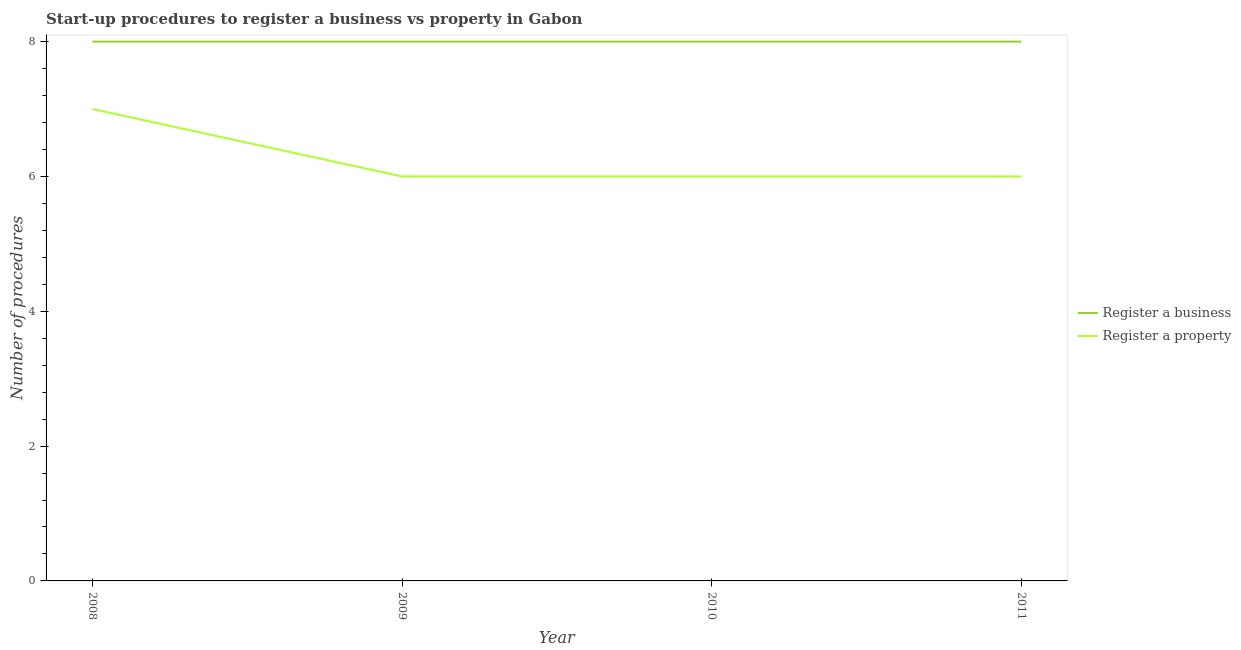Is the number of lines equal to the number of legend labels?
Provide a succinct answer. Yes. What is the number of procedures to register a business in 2009?
Provide a succinct answer. 8. Across all years, what is the maximum number of procedures to register a business?
Provide a succinct answer. 8. Across all years, what is the minimum number of procedures to register a property?
Your response must be concise. 6. In which year was the number of procedures to register a business maximum?
Provide a short and direct response. 2008. What is the total number of procedures to register a business in the graph?
Your answer should be very brief. 32. What is the difference between the number of procedures to register a property in 2009 and the number of procedures to register a business in 2008?
Offer a very short reply. -2. What is the average number of procedures to register a business per year?
Make the answer very short. 8. In the year 2009, what is the difference between the number of procedures to register a business and number of procedures to register a property?
Your answer should be compact. 2. In how many years, is the number of procedures to register a business greater than 7.2?
Your answer should be very brief. 4. Is the number of procedures to register a property in 2009 less than that in 2011?
Provide a short and direct response. No. Is the difference between the number of procedures to register a business in 2008 and 2011 greater than the difference between the number of procedures to register a property in 2008 and 2011?
Ensure brevity in your answer.  No. In how many years, is the number of procedures to register a business greater than the average number of procedures to register a business taken over all years?
Your answer should be compact. 0. Does the number of procedures to register a business monotonically increase over the years?
Make the answer very short. No. How many lines are there?
Offer a terse response. 2. How many years are there in the graph?
Provide a succinct answer. 4. Does the graph contain any zero values?
Keep it short and to the point. No. What is the title of the graph?
Provide a short and direct response. Start-up procedures to register a business vs property in Gabon. Does "Attending school" appear as one of the legend labels in the graph?
Provide a short and direct response. No. What is the label or title of the X-axis?
Make the answer very short. Year. What is the label or title of the Y-axis?
Provide a short and direct response. Number of procedures. What is the Number of procedures in Register a business in 2009?
Keep it short and to the point. 8. What is the Number of procedures of Register a property in 2010?
Offer a very short reply. 6. What is the Number of procedures of Register a business in 2011?
Give a very brief answer. 8. What is the Number of procedures of Register a property in 2011?
Your answer should be very brief. 6. Across all years, what is the maximum Number of procedures of Register a property?
Provide a succinct answer. 7. Across all years, what is the minimum Number of procedures in Register a business?
Make the answer very short. 8. Across all years, what is the minimum Number of procedures of Register a property?
Make the answer very short. 6. What is the total Number of procedures in Register a property in the graph?
Offer a very short reply. 25. What is the difference between the Number of procedures of Register a property in 2008 and that in 2009?
Your response must be concise. 1. What is the difference between the Number of procedures of Register a business in 2008 and that in 2010?
Ensure brevity in your answer.  0. What is the difference between the Number of procedures of Register a property in 2008 and that in 2010?
Ensure brevity in your answer.  1. What is the difference between the Number of procedures of Register a business in 2008 and that in 2011?
Provide a succinct answer. 0. What is the difference between the Number of procedures of Register a business in 2009 and that in 2010?
Offer a very short reply. 0. What is the difference between the Number of procedures of Register a business in 2008 and the Number of procedures of Register a property in 2009?
Offer a terse response. 2. What is the difference between the Number of procedures in Register a business in 2009 and the Number of procedures in Register a property in 2010?
Keep it short and to the point. 2. What is the average Number of procedures in Register a property per year?
Offer a very short reply. 6.25. In the year 2008, what is the difference between the Number of procedures in Register a business and Number of procedures in Register a property?
Provide a short and direct response. 1. In the year 2009, what is the difference between the Number of procedures of Register a business and Number of procedures of Register a property?
Ensure brevity in your answer.  2. What is the ratio of the Number of procedures of Register a business in 2008 to that in 2009?
Ensure brevity in your answer.  1. What is the ratio of the Number of procedures of Register a property in 2008 to that in 2009?
Keep it short and to the point. 1.17. What is the ratio of the Number of procedures in Register a business in 2008 to that in 2010?
Give a very brief answer. 1. What is the ratio of the Number of procedures of Register a property in 2008 to that in 2010?
Offer a very short reply. 1.17. What is the ratio of the Number of procedures in Register a business in 2008 to that in 2011?
Provide a short and direct response. 1. What is the ratio of the Number of procedures in Register a property in 2008 to that in 2011?
Offer a terse response. 1.17. What is the ratio of the Number of procedures in Register a business in 2009 to that in 2010?
Keep it short and to the point. 1. What is the ratio of the Number of procedures of Register a property in 2009 to that in 2010?
Your answer should be compact. 1. What is the ratio of the Number of procedures of Register a property in 2009 to that in 2011?
Offer a terse response. 1. What is the ratio of the Number of procedures of Register a business in 2010 to that in 2011?
Keep it short and to the point. 1. What is the ratio of the Number of procedures in Register a property in 2010 to that in 2011?
Offer a very short reply. 1. What is the difference between the highest and the second highest Number of procedures in Register a business?
Offer a very short reply. 0. 